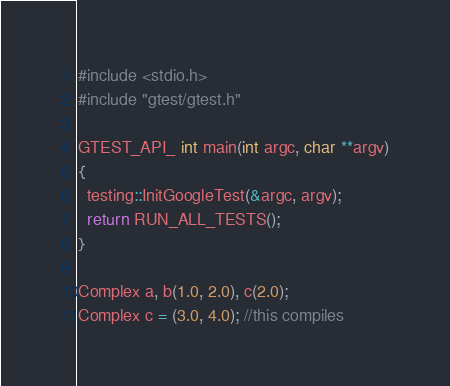Convert code to text. <code><loc_0><loc_0><loc_500><loc_500><_C++_>#include <stdio.h>
#include "gtest/gtest.h"

GTEST_API_ int main(int argc, char **argv)
{
  testing::InitGoogleTest(&argc, argv);
  return RUN_ALL_TESTS();
}

Complex a, b(1.0, 2.0), c(2.0);
Complex c = (3.0, 4.0); //this compiles</code> 